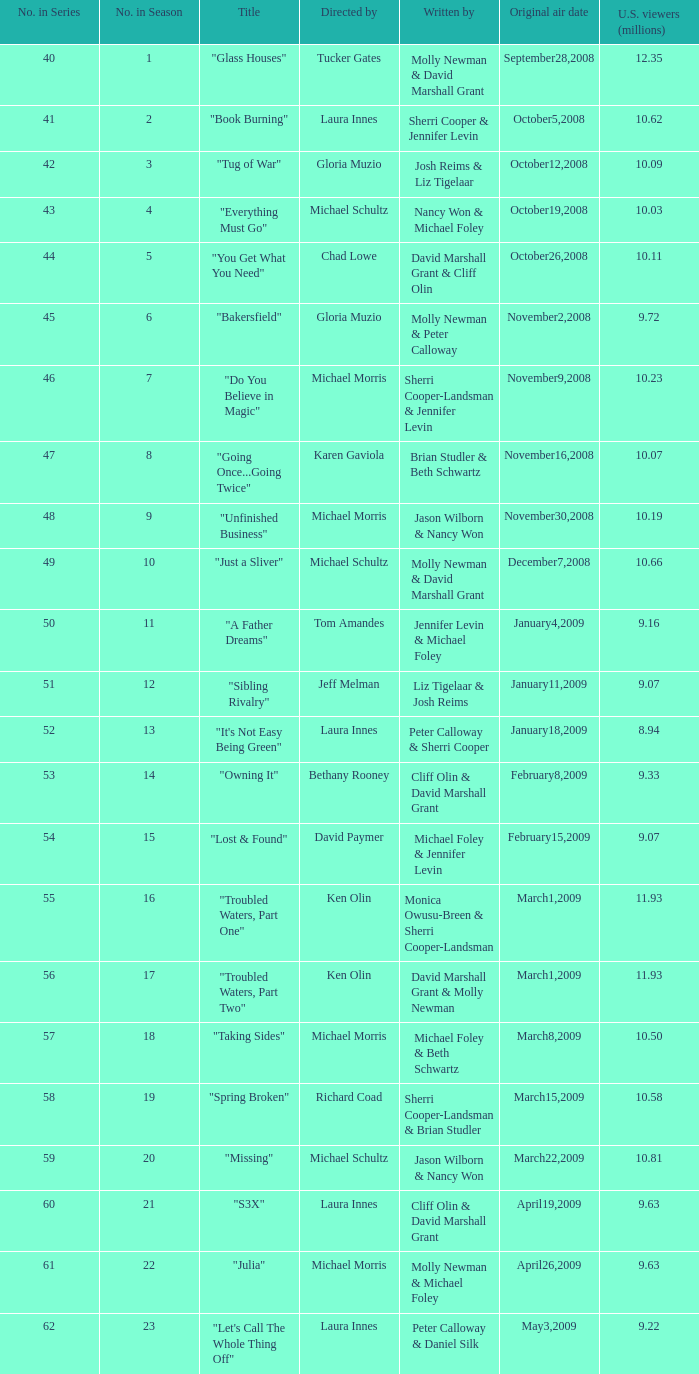When did the episode viewed by 10.50 millions of people in the US run for the first time? March8,2009. 